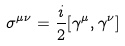Convert formula to latex. <formula><loc_0><loc_0><loc_500><loc_500>\sigma ^ { \mu \nu } = \frac { i } { 2 } [ \gamma ^ { \mu } , \gamma ^ { \nu } ]</formula> 